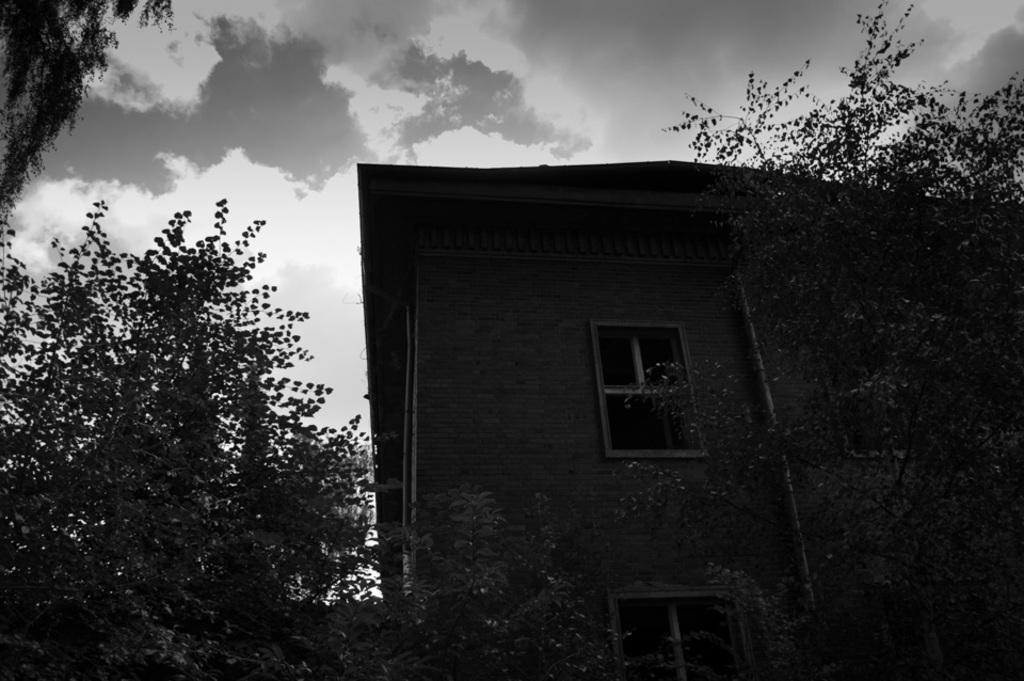In one or two sentences, can you explain what this image depicts? It is the black and white image in which there is a building in the middle. At the top there is the sky. There are trees around the building. 